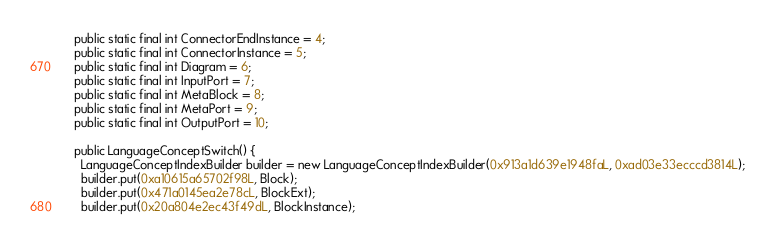Convert code to text. <code><loc_0><loc_0><loc_500><loc_500><_Java_>  public static final int ConnectorEndInstance = 4;
  public static final int ConnectorInstance = 5;
  public static final int Diagram = 6;
  public static final int InputPort = 7;
  public static final int MetaBlock = 8;
  public static final int MetaPort = 9;
  public static final int OutputPort = 10;

  public LanguageConceptSwitch() {
    LanguageConceptIndexBuilder builder = new LanguageConceptIndexBuilder(0x913a1d639e1948faL, 0xad03e33ecccd3814L);
    builder.put(0xa10615a65702f98L, Block);
    builder.put(0x471a0145ea2e78cL, BlockExt);
    builder.put(0x20a804e2ec43f49dL, BlockInstance);</code> 